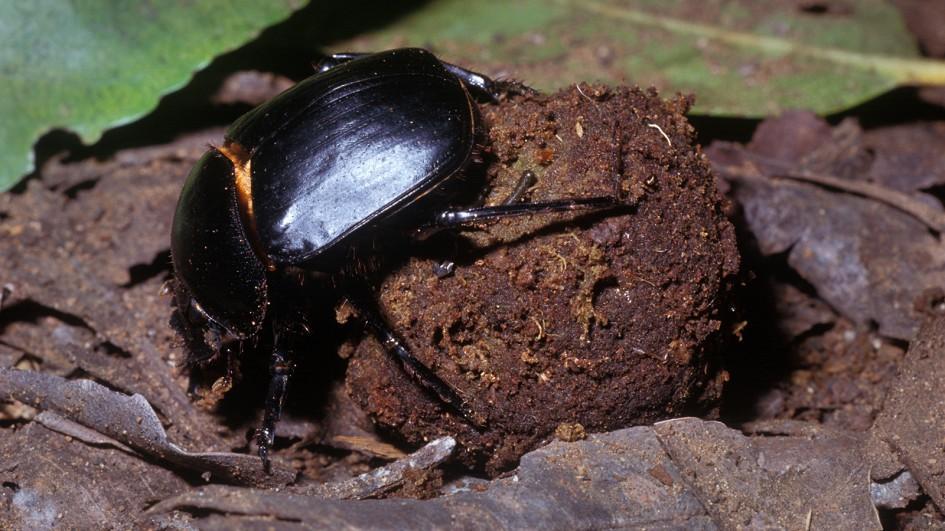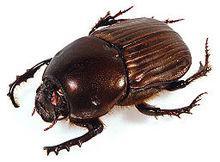The first image is the image on the left, the second image is the image on the right. For the images shown, is this caption "Both images show beetles on dung balls with their bodies in the same general pose and location." true? Answer yes or no. No. The first image is the image on the left, the second image is the image on the right. For the images shown, is this caption "A beetle is turned toward the left side of the photo in both images." true? Answer yes or no. Yes. 